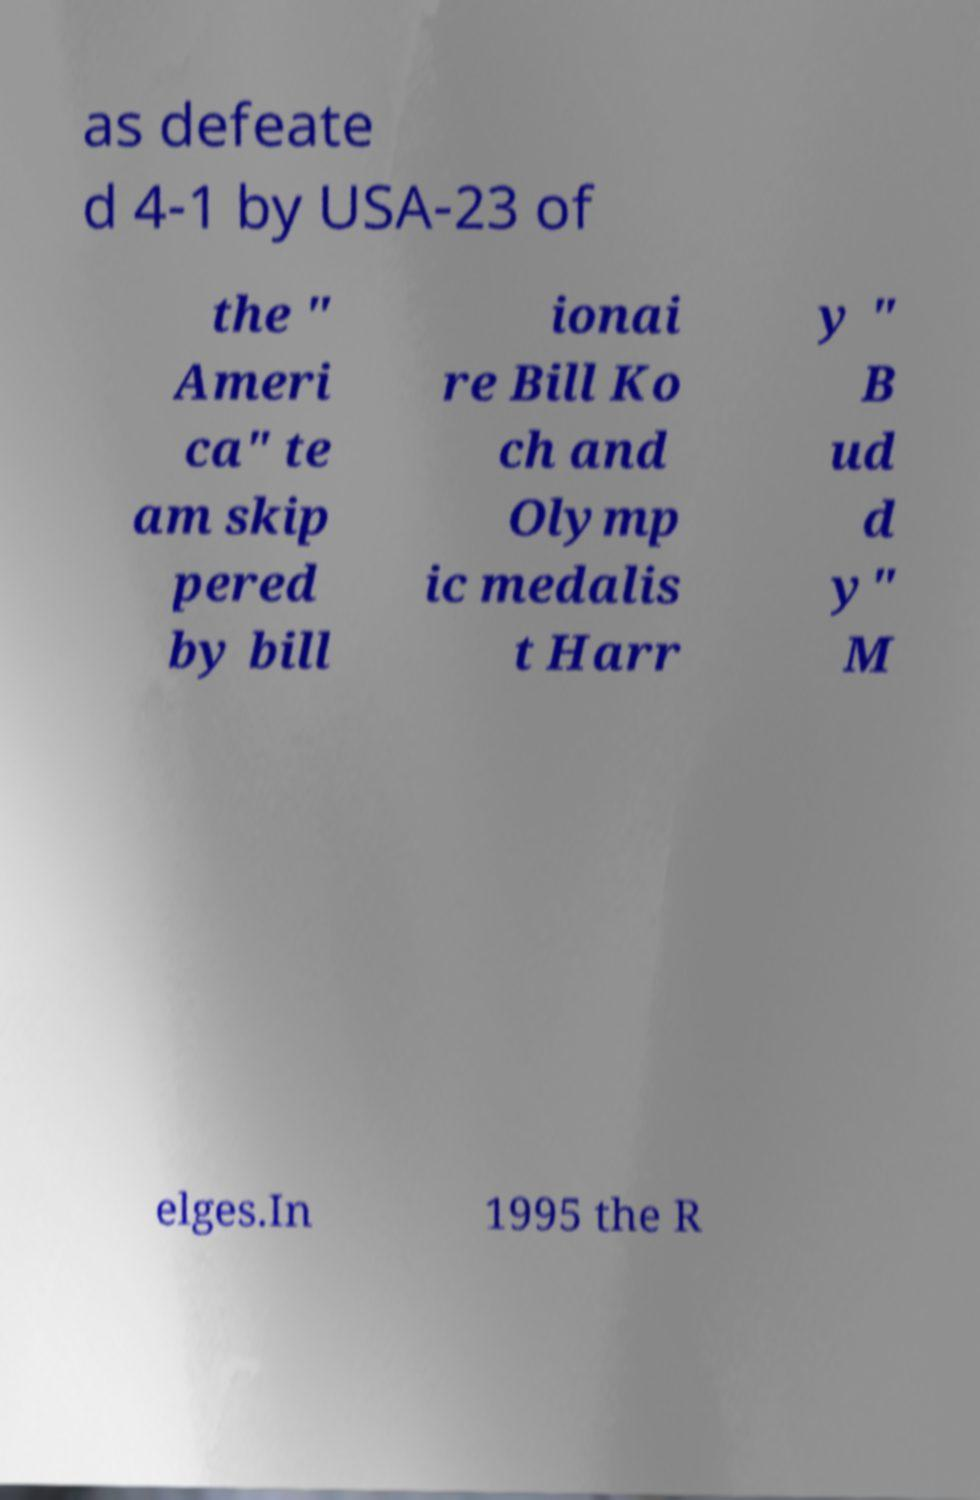What messages or text are displayed in this image? I need them in a readable, typed format. as defeate d 4-1 by USA-23 of the " Ameri ca" te am skip pered by bill ionai re Bill Ko ch and Olymp ic medalis t Harr y " B ud d y" M elges.In 1995 the R 